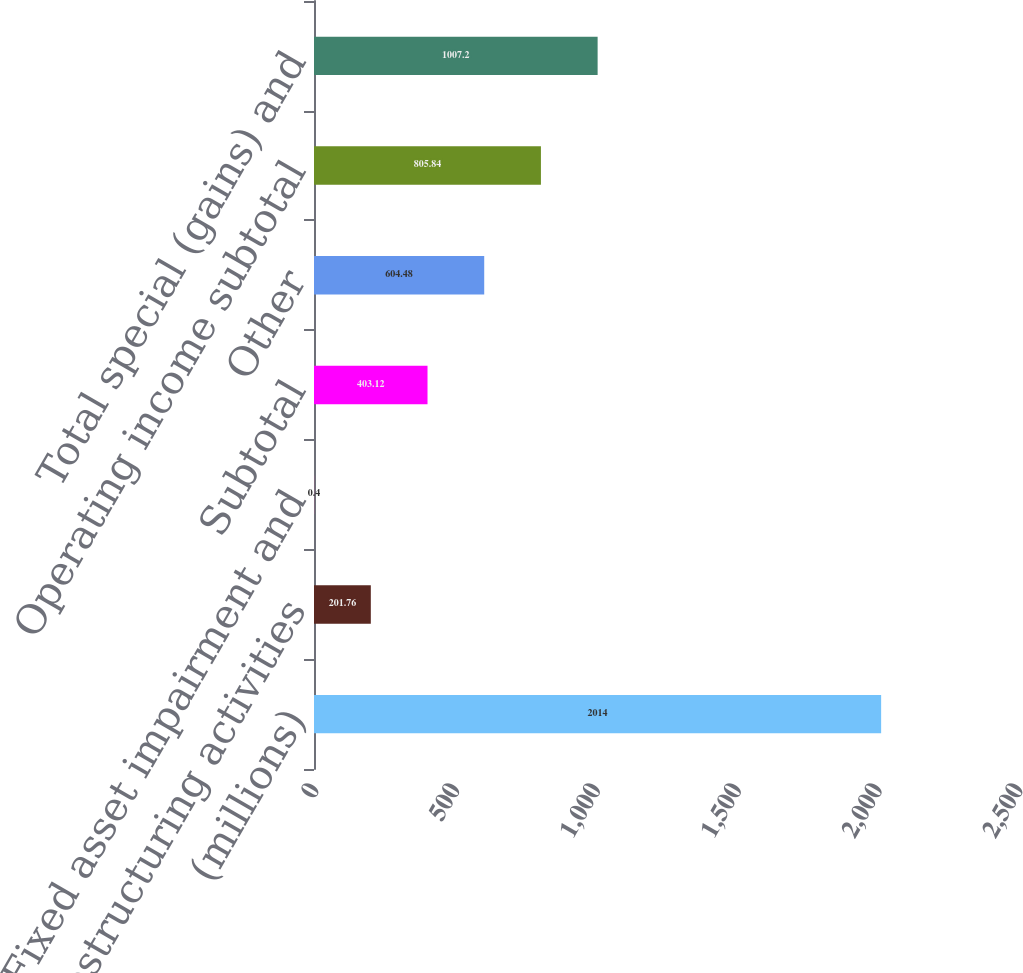Convert chart. <chart><loc_0><loc_0><loc_500><loc_500><bar_chart><fcel>(millions)<fcel>Restructuring activities<fcel>Fixed asset impairment and<fcel>Subtotal<fcel>Other<fcel>Operating income subtotal<fcel>Total special (gains) and<nl><fcel>2014<fcel>201.76<fcel>0.4<fcel>403.12<fcel>604.48<fcel>805.84<fcel>1007.2<nl></chart> 